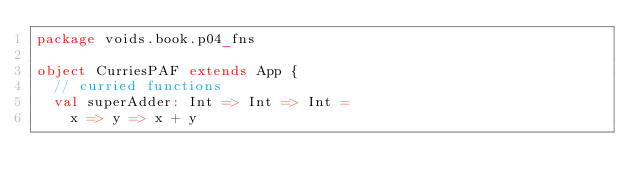Convert code to text. <code><loc_0><loc_0><loc_500><loc_500><_Scala_>package voids.book.p04_fns

object CurriesPAF extends App {
  // curried functions
  val superAdder: Int => Int => Int =
    x => y => x + y
</code> 